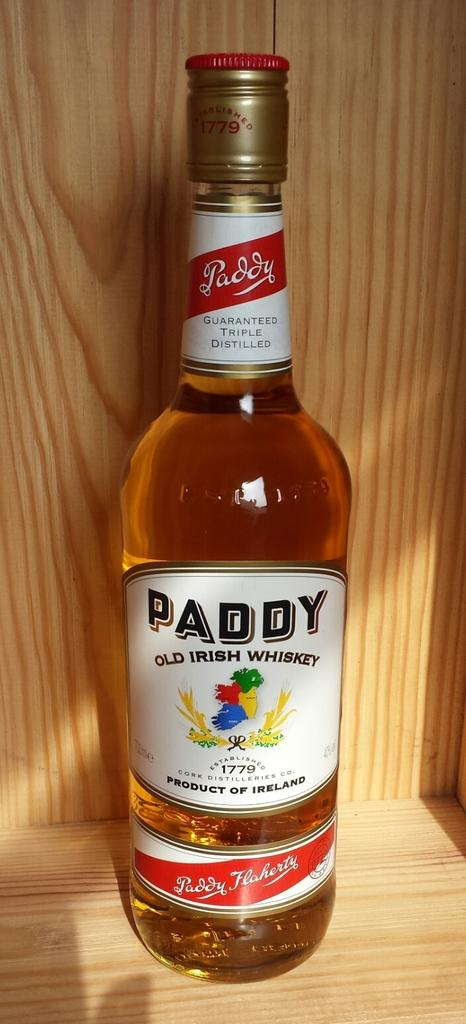<image>
Offer a succinct explanation of the picture presented. An unopened bottle of Paddy whiskey is sitting on a wooden display. 